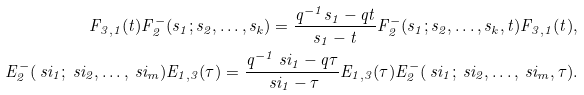Convert formula to latex. <formula><loc_0><loc_0><loc_500><loc_500>F _ { 3 , 1 } ( t ) F ^ { - } _ { 2 } ( s _ { 1 } ; s _ { 2 } , \dots , s _ { k } ) = \frac { q ^ { - 1 } s _ { 1 } - q t } { s _ { 1 } - t } F ^ { - } _ { 2 } ( s _ { 1 } ; s _ { 2 } , \dots , s _ { k } , t ) F _ { 3 , 1 } ( t ) , \\ E ^ { - } _ { 2 } ( \ s i _ { 1 } ; \ s i _ { 2 } , \dots , \ s i _ { m } ) E _ { 1 , 3 } ( \tau ) = \frac { q ^ { - 1 } \ s i _ { 1 } - q \tau } { \ s i _ { 1 } - \tau } E _ { 1 , 3 } ( \tau ) E ^ { - } _ { 2 } ( \ s i _ { 1 } ; \ s i _ { 2 } , \dots , \ s i _ { m } , \tau ) .</formula> 